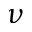Convert formula to latex. <formula><loc_0><loc_0><loc_500><loc_500>\nu</formula> 